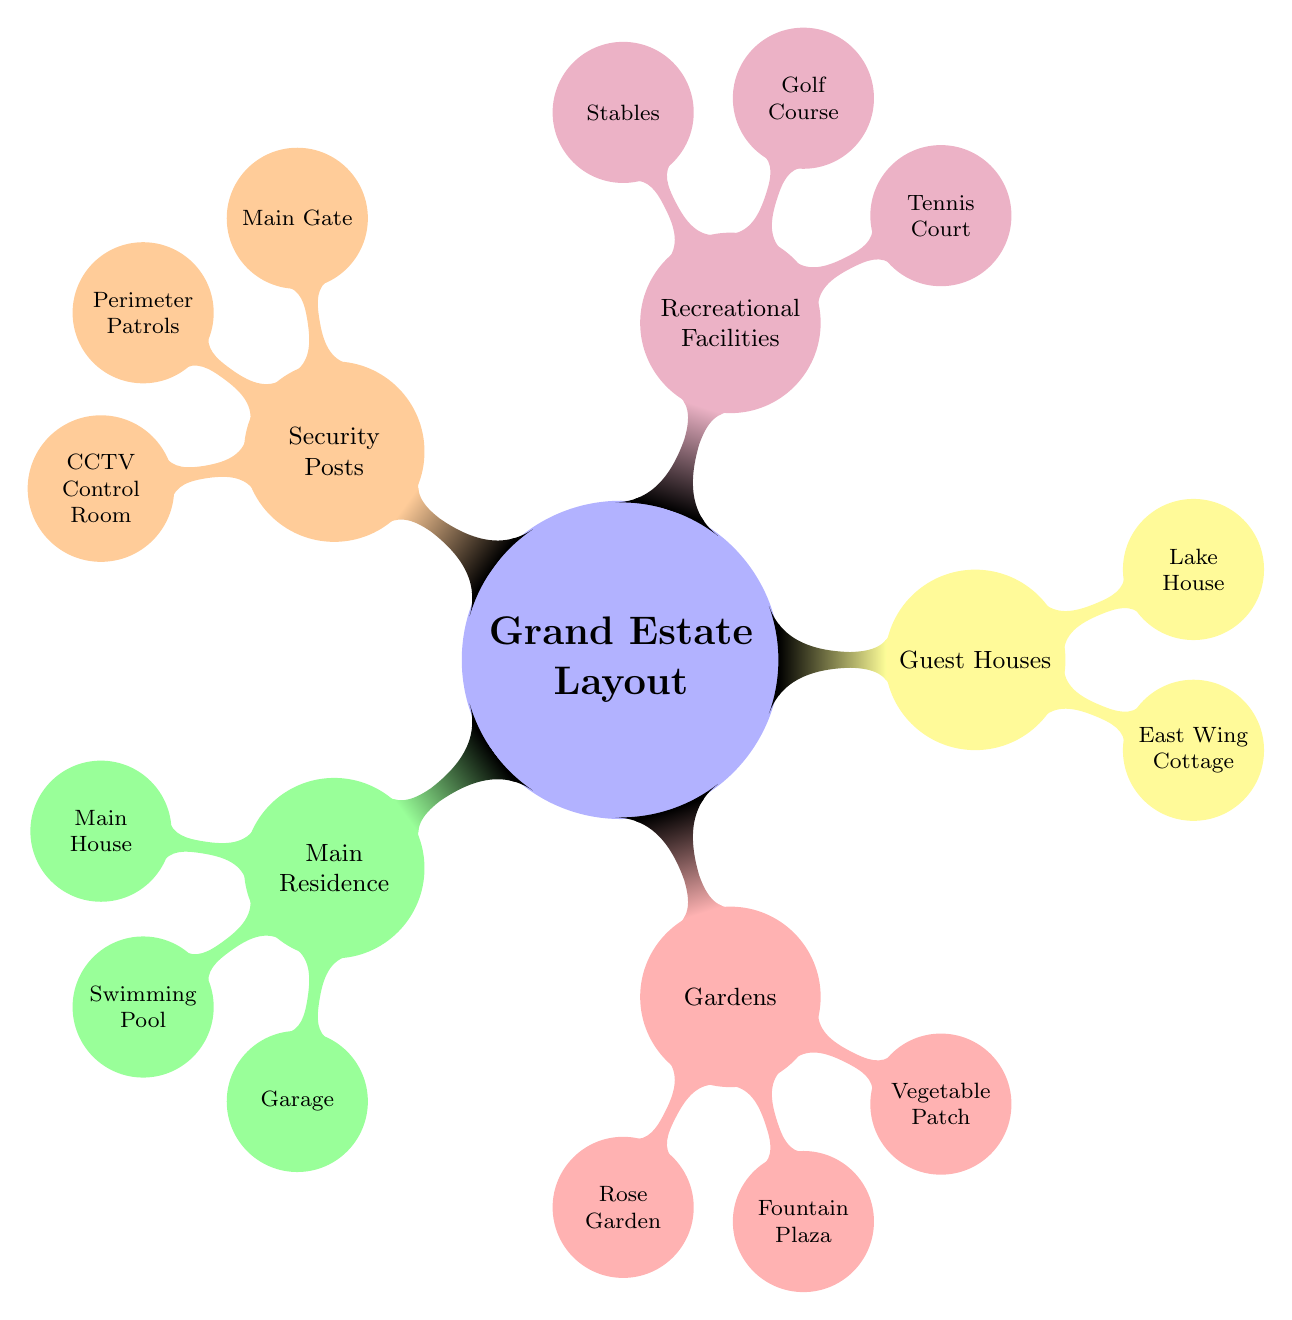What is the main feature of the residential area? The main feature of the residential area is the "Main House," which is the primary structure within the "Main Residence" section.
Answer: Main House How many gardens are there in total? There are three gardens listed under the "Gardens" section: Rose Garden, Fountain Plaza, and Vegetable Patch. Therefore, the total number of gardens is three.
Answer: 3 Which facility is located closest to the security posts? The "Main Gate" is part of the "Security Posts" section and is the facility closest to these security measures, making it the first point of entry.
Answer: Main Gate In which section would you find recreational activities? Recreational activities are found in the "Recreational Facilities" section, which includes amenities like the Tennis Court and Golf Course.
Answer: Recreational Facilities What type of garden has a specific focus on food production? The "Vegetable Patch" focuses specifically on food production and is categorized within the "Gardens."
Answer: Vegetable Patch How many guest houses are mentioned? There are two guest houses mentioned: East Wing Cottage and Lake House. Counting these gives a total of two guest houses.
Answer: 2 Which facility provides surveillance for the estate? The "CCTV Control Room" provides surveillance as part of the "Security Posts" ensuring the estate's safety.
Answer: CCTV Control Room What amenities are included under "Recreational Facilities"? The "Recreational Facilities" includes a Tennis Court, Golf Course, and Stables for varied recreational activities.
Answer: Tennis Court, Golf Course, Stables Which zone does the "Fountain Plaza" belong to? "Fountain Plaza" belongs to the "Gardens" zone, indicating it is part of the landscaping and open areas.
Answer: Gardens 